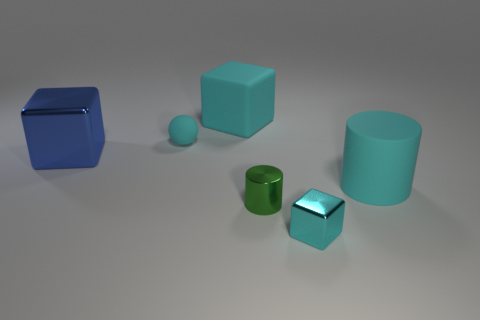What is the material of the cylinder on the left side of the cyan thing in front of the cylinder that is behind the small green shiny cylinder?
Ensure brevity in your answer.  Metal. Are there fewer small brown matte things than tiny green shiny objects?
Keep it short and to the point. Yes. Does the big cylinder have the same material as the small cyan ball?
Your response must be concise. Yes. What shape is the tiny object that is the same color as the tiny cube?
Give a very brief answer. Sphere. Is the color of the large block on the right side of the matte sphere the same as the matte sphere?
Your answer should be compact. Yes. What number of big cyan objects are in front of the small cyan thing that is in front of the large cyan matte cylinder?
Provide a short and direct response. 0. The cube that is the same size as the green object is what color?
Provide a succinct answer. Cyan. There is a small object in front of the small cylinder; what is its material?
Give a very brief answer. Metal. What is the tiny thing that is both behind the tiny cube and right of the large cyan matte cube made of?
Keep it short and to the point. Metal. There is a block to the right of the green object; is it the same size as the cyan ball?
Ensure brevity in your answer.  Yes. 